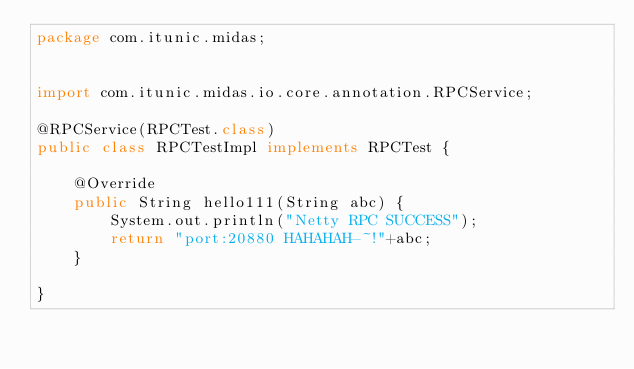<code> <loc_0><loc_0><loc_500><loc_500><_Java_>package com.itunic.midas;


import com.itunic.midas.io.core.annotation.RPCService;

@RPCService(RPCTest.class)
public class RPCTestImpl implements RPCTest {

	@Override
	public String hello111(String abc) {
		System.out.println("Netty RPC SUCCESS");
		return "port:20880 HAHAHAH-~!"+abc;
	}

}
</code> 